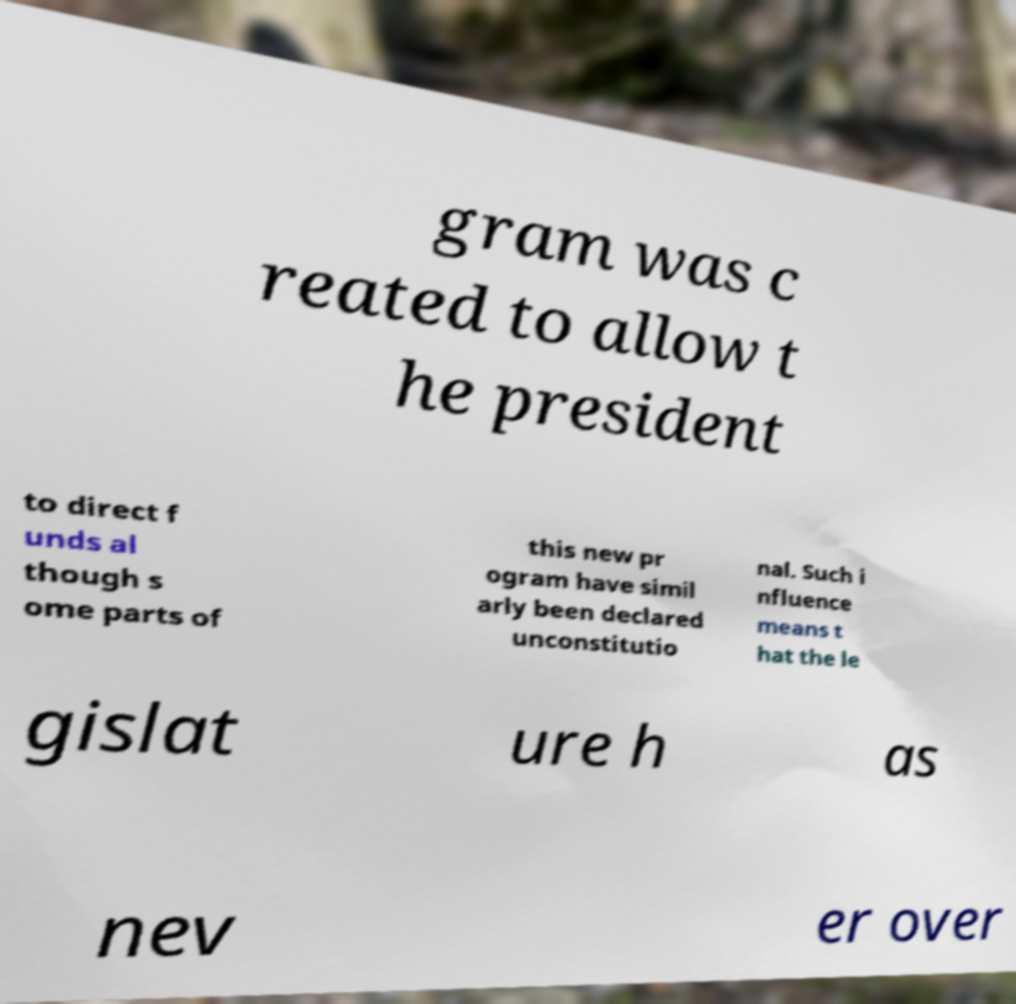Can you read and provide the text displayed in the image?This photo seems to have some interesting text. Can you extract and type it out for me? gram was c reated to allow t he president to direct f unds al though s ome parts of this new pr ogram have simil arly been declared unconstitutio nal. Such i nfluence means t hat the le gislat ure h as nev er over 